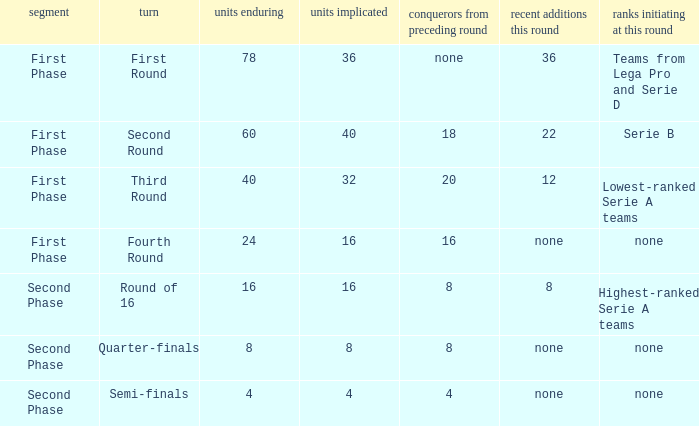From the round name of third round; what would the new entries this round that would be found? 12.0. 